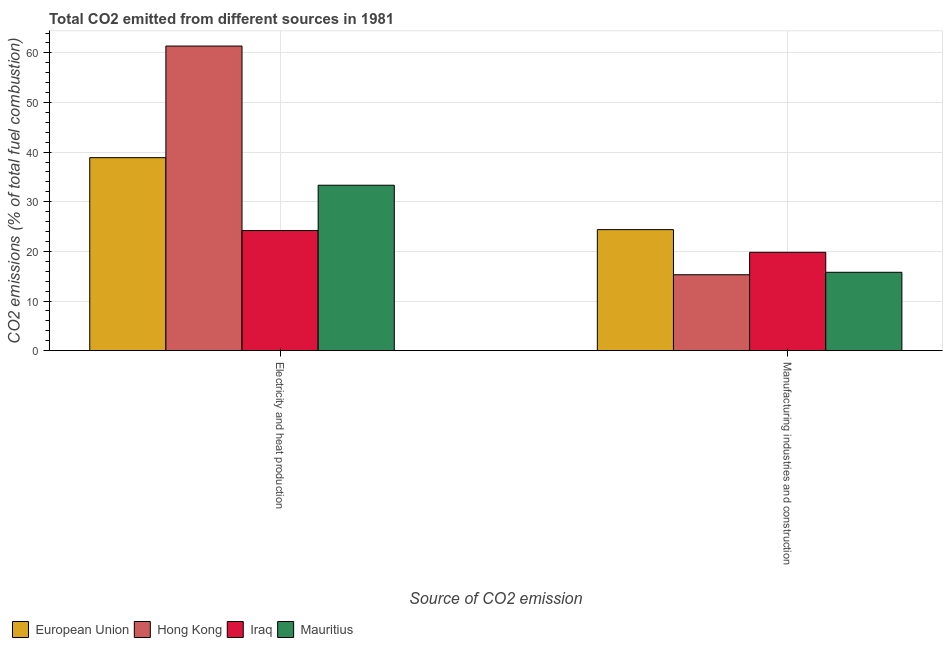How many different coloured bars are there?
Provide a short and direct response. 4. How many groups of bars are there?
Your answer should be very brief. 2. Are the number of bars on each tick of the X-axis equal?
Provide a succinct answer. Yes. How many bars are there on the 1st tick from the right?
Make the answer very short. 4. What is the label of the 2nd group of bars from the left?
Your response must be concise. Manufacturing industries and construction. What is the co2 emissions due to electricity and heat production in European Union?
Keep it short and to the point. 38.89. Across all countries, what is the maximum co2 emissions due to manufacturing industries?
Ensure brevity in your answer.  24.38. Across all countries, what is the minimum co2 emissions due to manufacturing industries?
Provide a short and direct response. 15.3. In which country was the co2 emissions due to electricity and heat production maximum?
Make the answer very short. Hong Kong. In which country was the co2 emissions due to manufacturing industries minimum?
Offer a terse response. Hong Kong. What is the total co2 emissions due to electricity and heat production in the graph?
Ensure brevity in your answer.  157.8. What is the difference between the co2 emissions due to electricity and heat production in Iraq and that in Mauritius?
Your answer should be very brief. -9.13. What is the difference between the co2 emissions due to electricity and heat production in Hong Kong and the co2 emissions due to manufacturing industries in Iraq?
Your response must be concise. 41.56. What is the average co2 emissions due to manufacturing industries per country?
Your response must be concise. 18.82. What is the difference between the co2 emissions due to manufacturing industries and co2 emissions due to electricity and heat production in Hong Kong?
Your answer should be very brief. -46.08. In how many countries, is the co2 emissions due to manufacturing industries greater than 10 %?
Keep it short and to the point. 4. What is the ratio of the co2 emissions due to electricity and heat production in European Union to that in Mauritius?
Your answer should be compact. 1.17. Is the co2 emissions due to electricity and heat production in Mauritius less than that in European Union?
Make the answer very short. Yes. What does the 3rd bar from the left in Electricity and heat production represents?
Your response must be concise. Iraq. What does the 4th bar from the right in Electricity and heat production represents?
Your answer should be compact. European Union. How many countries are there in the graph?
Your answer should be very brief. 4. What is the difference between two consecutive major ticks on the Y-axis?
Provide a succinct answer. 10. Does the graph contain grids?
Your response must be concise. Yes. How many legend labels are there?
Your answer should be compact. 4. How are the legend labels stacked?
Your answer should be very brief. Horizontal. What is the title of the graph?
Make the answer very short. Total CO2 emitted from different sources in 1981. Does "Tunisia" appear as one of the legend labels in the graph?
Make the answer very short. No. What is the label or title of the X-axis?
Your response must be concise. Source of CO2 emission. What is the label or title of the Y-axis?
Your answer should be compact. CO2 emissions (% of total fuel combustion). What is the CO2 emissions (% of total fuel combustion) in European Union in Electricity and heat production?
Provide a succinct answer. 38.89. What is the CO2 emissions (% of total fuel combustion) in Hong Kong in Electricity and heat production?
Give a very brief answer. 61.38. What is the CO2 emissions (% of total fuel combustion) in Iraq in Electricity and heat production?
Your answer should be very brief. 24.2. What is the CO2 emissions (% of total fuel combustion) in Mauritius in Electricity and heat production?
Keep it short and to the point. 33.33. What is the CO2 emissions (% of total fuel combustion) in European Union in Manufacturing industries and construction?
Provide a short and direct response. 24.38. What is the CO2 emissions (% of total fuel combustion) of Hong Kong in Manufacturing industries and construction?
Your response must be concise. 15.3. What is the CO2 emissions (% of total fuel combustion) of Iraq in Manufacturing industries and construction?
Ensure brevity in your answer.  19.82. What is the CO2 emissions (% of total fuel combustion) of Mauritius in Manufacturing industries and construction?
Offer a terse response. 15.79. Across all Source of CO2 emission, what is the maximum CO2 emissions (% of total fuel combustion) of European Union?
Your answer should be very brief. 38.89. Across all Source of CO2 emission, what is the maximum CO2 emissions (% of total fuel combustion) of Hong Kong?
Your response must be concise. 61.38. Across all Source of CO2 emission, what is the maximum CO2 emissions (% of total fuel combustion) of Iraq?
Ensure brevity in your answer.  24.2. Across all Source of CO2 emission, what is the maximum CO2 emissions (% of total fuel combustion) in Mauritius?
Your response must be concise. 33.33. Across all Source of CO2 emission, what is the minimum CO2 emissions (% of total fuel combustion) of European Union?
Ensure brevity in your answer.  24.38. Across all Source of CO2 emission, what is the minimum CO2 emissions (% of total fuel combustion) in Hong Kong?
Your answer should be compact. 15.3. Across all Source of CO2 emission, what is the minimum CO2 emissions (% of total fuel combustion) in Iraq?
Offer a very short reply. 19.82. Across all Source of CO2 emission, what is the minimum CO2 emissions (% of total fuel combustion) in Mauritius?
Ensure brevity in your answer.  15.79. What is the total CO2 emissions (% of total fuel combustion) in European Union in the graph?
Your response must be concise. 63.27. What is the total CO2 emissions (% of total fuel combustion) in Hong Kong in the graph?
Ensure brevity in your answer.  76.67. What is the total CO2 emissions (% of total fuel combustion) of Iraq in the graph?
Offer a terse response. 44.02. What is the total CO2 emissions (% of total fuel combustion) in Mauritius in the graph?
Ensure brevity in your answer.  49.12. What is the difference between the CO2 emissions (% of total fuel combustion) of European Union in Electricity and heat production and that in Manufacturing industries and construction?
Provide a succinct answer. 14.51. What is the difference between the CO2 emissions (% of total fuel combustion) of Hong Kong in Electricity and heat production and that in Manufacturing industries and construction?
Ensure brevity in your answer.  46.08. What is the difference between the CO2 emissions (% of total fuel combustion) of Iraq in Electricity and heat production and that in Manufacturing industries and construction?
Offer a terse response. 4.39. What is the difference between the CO2 emissions (% of total fuel combustion) of Mauritius in Electricity and heat production and that in Manufacturing industries and construction?
Make the answer very short. 17.54. What is the difference between the CO2 emissions (% of total fuel combustion) of European Union in Electricity and heat production and the CO2 emissions (% of total fuel combustion) of Hong Kong in Manufacturing industries and construction?
Your answer should be very brief. 23.59. What is the difference between the CO2 emissions (% of total fuel combustion) of European Union in Electricity and heat production and the CO2 emissions (% of total fuel combustion) of Iraq in Manufacturing industries and construction?
Keep it short and to the point. 19.08. What is the difference between the CO2 emissions (% of total fuel combustion) in European Union in Electricity and heat production and the CO2 emissions (% of total fuel combustion) in Mauritius in Manufacturing industries and construction?
Offer a very short reply. 23.1. What is the difference between the CO2 emissions (% of total fuel combustion) in Hong Kong in Electricity and heat production and the CO2 emissions (% of total fuel combustion) in Iraq in Manufacturing industries and construction?
Make the answer very short. 41.56. What is the difference between the CO2 emissions (% of total fuel combustion) of Hong Kong in Electricity and heat production and the CO2 emissions (% of total fuel combustion) of Mauritius in Manufacturing industries and construction?
Provide a short and direct response. 45.59. What is the difference between the CO2 emissions (% of total fuel combustion) in Iraq in Electricity and heat production and the CO2 emissions (% of total fuel combustion) in Mauritius in Manufacturing industries and construction?
Give a very brief answer. 8.41. What is the average CO2 emissions (% of total fuel combustion) in European Union per Source of CO2 emission?
Offer a terse response. 31.64. What is the average CO2 emissions (% of total fuel combustion) of Hong Kong per Source of CO2 emission?
Provide a short and direct response. 38.34. What is the average CO2 emissions (% of total fuel combustion) in Iraq per Source of CO2 emission?
Provide a succinct answer. 22.01. What is the average CO2 emissions (% of total fuel combustion) of Mauritius per Source of CO2 emission?
Your answer should be compact. 24.56. What is the difference between the CO2 emissions (% of total fuel combustion) of European Union and CO2 emissions (% of total fuel combustion) of Hong Kong in Electricity and heat production?
Offer a terse response. -22.49. What is the difference between the CO2 emissions (% of total fuel combustion) in European Union and CO2 emissions (% of total fuel combustion) in Iraq in Electricity and heat production?
Keep it short and to the point. 14.69. What is the difference between the CO2 emissions (% of total fuel combustion) in European Union and CO2 emissions (% of total fuel combustion) in Mauritius in Electricity and heat production?
Offer a terse response. 5.56. What is the difference between the CO2 emissions (% of total fuel combustion) in Hong Kong and CO2 emissions (% of total fuel combustion) in Iraq in Electricity and heat production?
Offer a terse response. 37.18. What is the difference between the CO2 emissions (% of total fuel combustion) in Hong Kong and CO2 emissions (% of total fuel combustion) in Mauritius in Electricity and heat production?
Your response must be concise. 28.04. What is the difference between the CO2 emissions (% of total fuel combustion) of Iraq and CO2 emissions (% of total fuel combustion) of Mauritius in Electricity and heat production?
Provide a succinct answer. -9.13. What is the difference between the CO2 emissions (% of total fuel combustion) of European Union and CO2 emissions (% of total fuel combustion) of Hong Kong in Manufacturing industries and construction?
Offer a very short reply. 9.09. What is the difference between the CO2 emissions (% of total fuel combustion) in European Union and CO2 emissions (% of total fuel combustion) in Iraq in Manufacturing industries and construction?
Provide a short and direct response. 4.57. What is the difference between the CO2 emissions (% of total fuel combustion) of European Union and CO2 emissions (% of total fuel combustion) of Mauritius in Manufacturing industries and construction?
Offer a terse response. 8.59. What is the difference between the CO2 emissions (% of total fuel combustion) of Hong Kong and CO2 emissions (% of total fuel combustion) of Iraq in Manufacturing industries and construction?
Keep it short and to the point. -4.52. What is the difference between the CO2 emissions (% of total fuel combustion) of Hong Kong and CO2 emissions (% of total fuel combustion) of Mauritius in Manufacturing industries and construction?
Offer a very short reply. -0.49. What is the difference between the CO2 emissions (% of total fuel combustion) in Iraq and CO2 emissions (% of total fuel combustion) in Mauritius in Manufacturing industries and construction?
Give a very brief answer. 4.03. What is the ratio of the CO2 emissions (% of total fuel combustion) in European Union in Electricity and heat production to that in Manufacturing industries and construction?
Make the answer very short. 1.59. What is the ratio of the CO2 emissions (% of total fuel combustion) of Hong Kong in Electricity and heat production to that in Manufacturing industries and construction?
Offer a very short reply. 4.01. What is the ratio of the CO2 emissions (% of total fuel combustion) of Iraq in Electricity and heat production to that in Manufacturing industries and construction?
Your response must be concise. 1.22. What is the ratio of the CO2 emissions (% of total fuel combustion) of Mauritius in Electricity and heat production to that in Manufacturing industries and construction?
Give a very brief answer. 2.11. What is the difference between the highest and the second highest CO2 emissions (% of total fuel combustion) in European Union?
Offer a terse response. 14.51. What is the difference between the highest and the second highest CO2 emissions (% of total fuel combustion) in Hong Kong?
Give a very brief answer. 46.08. What is the difference between the highest and the second highest CO2 emissions (% of total fuel combustion) in Iraq?
Provide a succinct answer. 4.39. What is the difference between the highest and the second highest CO2 emissions (% of total fuel combustion) of Mauritius?
Your answer should be very brief. 17.54. What is the difference between the highest and the lowest CO2 emissions (% of total fuel combustion) in European Union?
Your response must be concise. 14.51. What is the difference between the highest and the lowest CO2 emissions (% of total fuel combustion) of Hong Kong?
Your answer should be very brief. 46.08. What is the difference between the highest and the lowest CO2 emissions (% of total fuel combustion) of Iraq?
Offer a very short reply. 4.39. What is the difference between the highest and the lowest CO2 emissions (% of total fuel combustion) of Mauritius?
Your response must be concise. 17.54. 